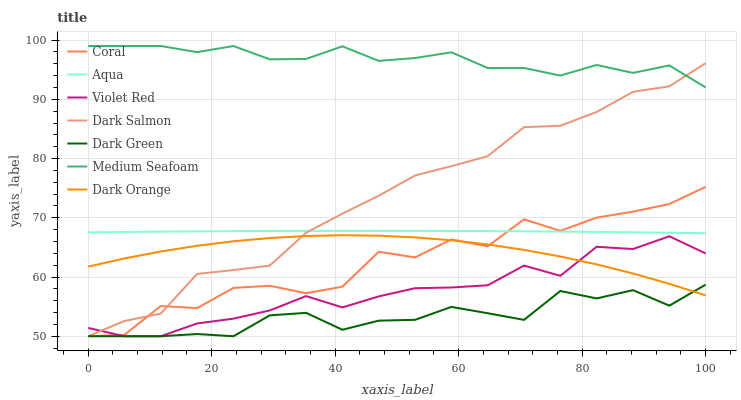Does Dark Green have the minimum area under the curve?
Answer yes or no. Yes. Does Medium Seafoam have the maximum area under the curve?
Answer yes or no. Yes. Does Violet Red have the minimum area under the curve?
Answer yes or no. No. Does Violet Red have the maximum area under the curve?
Answer yes or no. No. Is Aqua the smoothest?
Answer yes or no. Yes. Is Coral the roughest?
Answer yes or no. Yes. Is Violet Red the smoothest?
Answer yes or no. No. Is Violet Red the roughest?
Answer yes or no. No. Does Aqua have the lowest value?
Answer yes or no. No. Does Violet Red have the highest value?
Answer yes or no. No. Is Dark Orange less than Aqua?
Answer yes or no. Yes. Is Medium Seafoam greater than Coral?
Answer yes or no. Yes. Does Dark Orange intersect Aqua?
Answer yes or no. No. 